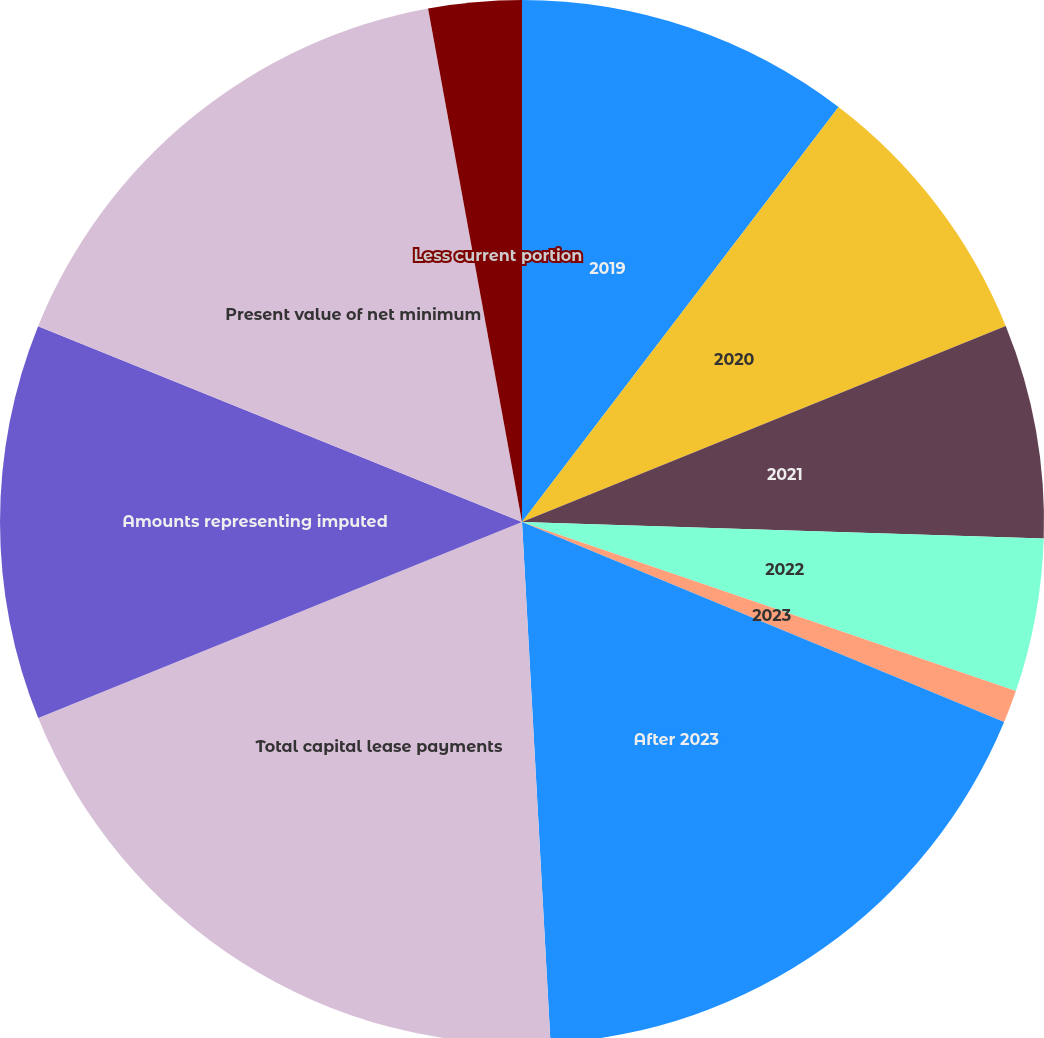Convert chart to OTSL. <chart><loc_0><loc_0><loc_500><loc_500><pie_chart><fcel>2019<fcel>2020<fcel>2021<fcel>2022<fcel>2023<fcel>After 2023<fcel>Total capital lease payments<fcel>Amounts representing imputed<fcel>Present value of net minimum<fcel>Less current portion<nl><fcel>10.37%<fcel>8.5%<fcel>6.63%<fcel>4.75%<fcel>1.01%<fcel>17.87%<fcel>19.74%<fcel>12.25%<fcel>16.0%<fcel>2.88%<nl></chart> 